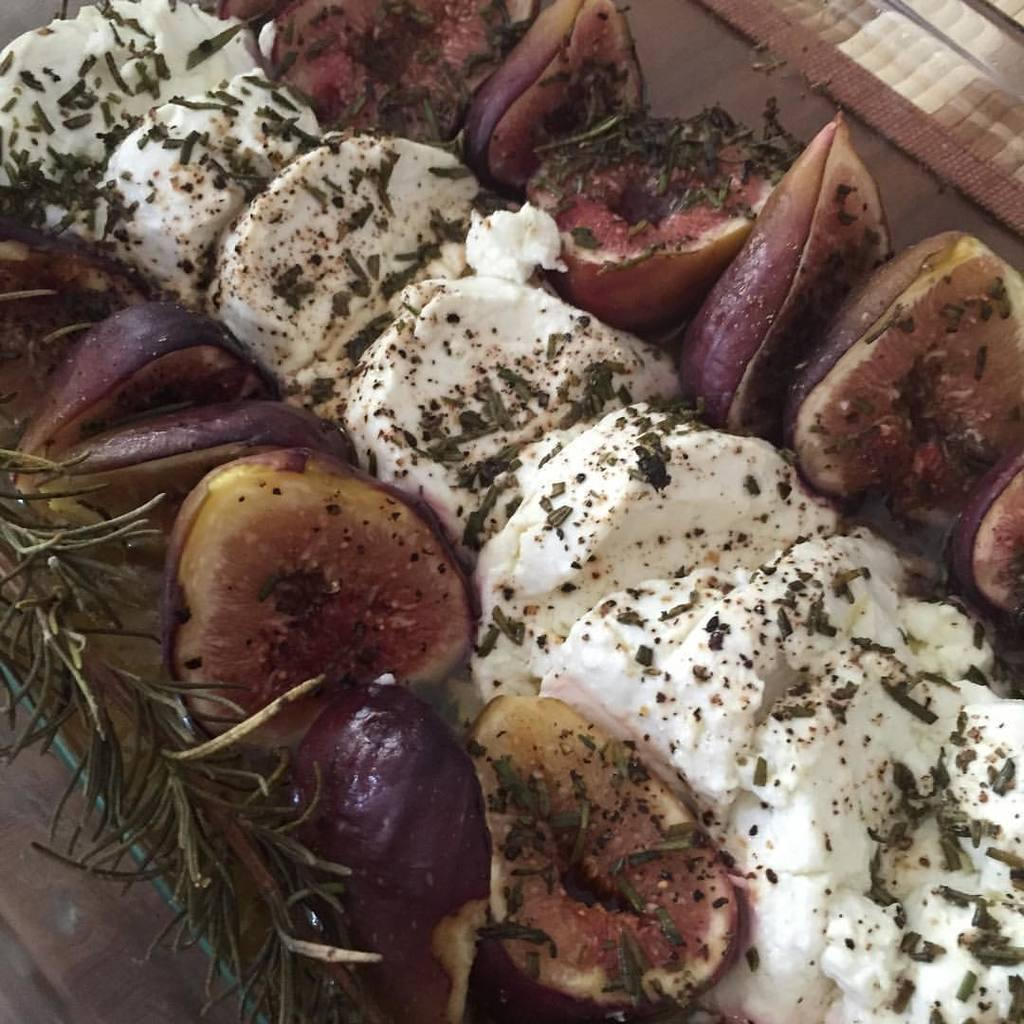What is present in the image? There is food in the image. Is there a spy driving a car in the image? There is no mention of a spy or a car in the image; it only contains food. 